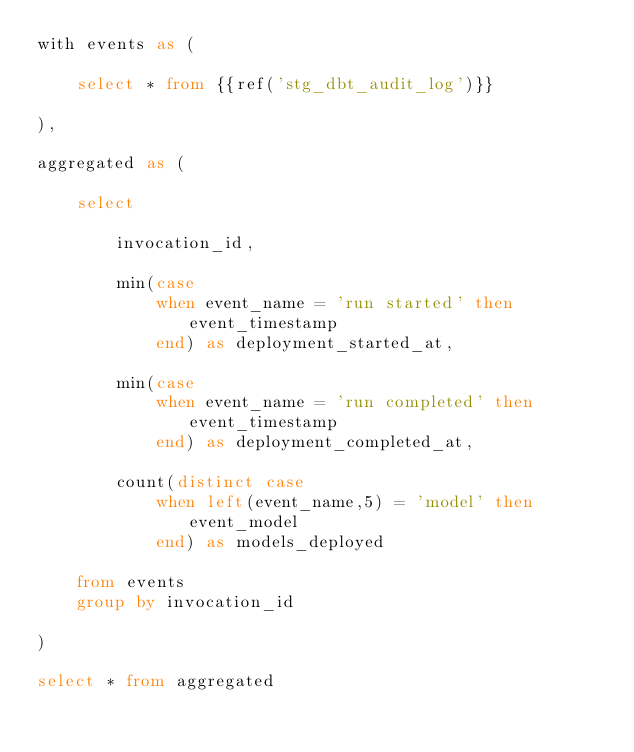Convert code to text. <code><loc_0><loc_0><loc_500><loc_500><_SQL_>with events as (

    select * from {{ref('stg_dbt_audit_log')}}

),

aggregated as (

    select 
    
        invocation_id,
    
        min(case 
            when event_name = 'run started' then event_timestamp 
            end) as deployment_started_at,
    
        min(case 
            when event_name = 'run completed' then event_timestamp 
            end) as deployment_completed_at,
            
        count(distinct case 
            when left(event_name,5) = 'model' then event_model 
            end) as models_deployed
    
    from events
    group by invocation_id

)

select * from aggregated</code> 